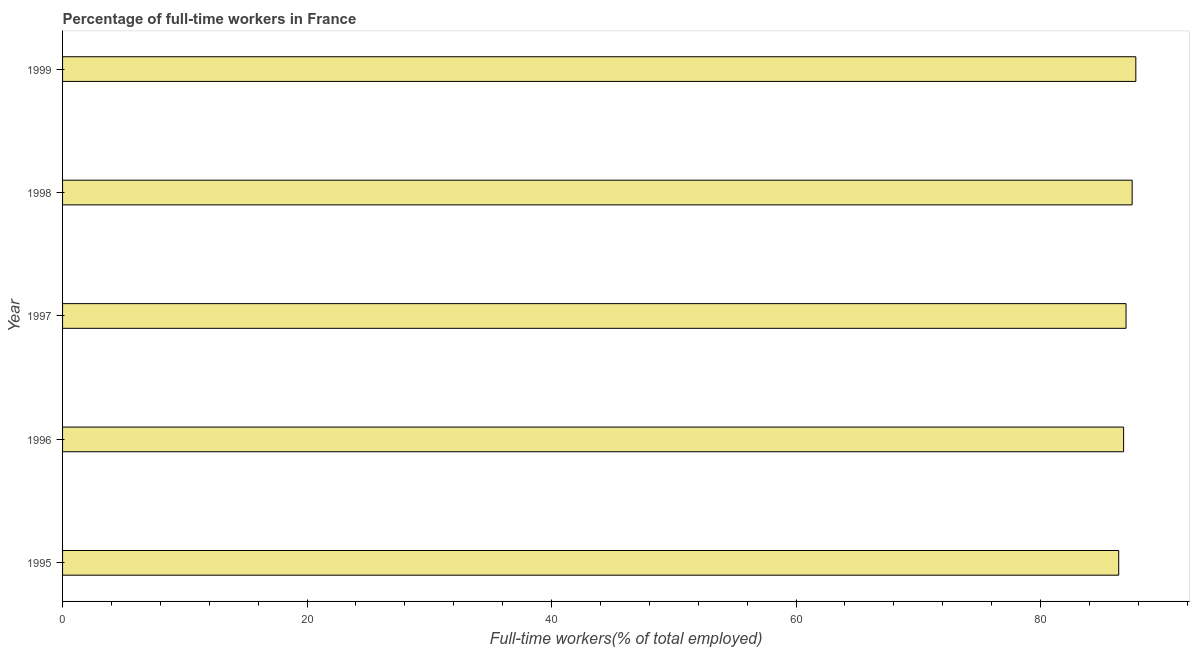What is the title of the graph?
Keep it short and to the point. Percentage of full-time workers in France. What is the label or title of the X-axis?
Provide a succinct answer. Full-time workers(% of total employed). What is the label or title of the Y-axis?
Your answer should be very brief. Year. Across all years, what is the maximum percentage of full-time workers?
Keep it short and to the point. 87.8. Across all years, what is the minimum percentage of full-time workers?
Your response must be concise. 86.4. In which year was the percentage of full-time workers minimum?
Provide a succinct answer. 1995. What is the sum of the percentage of full-time workers?
Ensure brevity in your answer.  435.5. What is the average percentage of full-time workers per year?
Give a very brief answer. 87.1. What is the median percentage of full-time workers?
Offer a very short reply. 87. In how many years, is the percentage of full-time workers greater than 52 %?
Offer a terse response. 5. Is the percentage of full-time workers in 1995 less than that in 1999?
Provide a succinct answer. Yes. What is the difference between the highest and the second highest percentage of full-time workers?
Make the answer very short. 0.3. How many bars are there?
Your answer should be compact. 5. How many years are there in the graph?
Your answer should be compact. 5. What is the difference between two consecutive major ticks on the X-axis?
Provide a short and direct response. 20. What is the Full-time workers(% of total employed) in 1995?
Your answer should be compact. 86.4. What is the Full-time workers(% of total employed) of 1996?
Your response must be concise. 86.8. What is the Full-time workers(% of total employed) of 1997?
Ensure brevity in your answer.  87. What is the Full-time workers(% of total employed) in 1998?
Your response must be concise. 87.5. What is the Full-time workers(% of total employed) in 1999?
Provide a short and direct response. 87.8. What is the difference between the Full-time workers(% of total employed) in 1995 and 1996?
Your answer should be compact. -0.4. What is the difference between the Full-time workers(% of total employed) in 1995 and 1998?
Provide a short and direct response. -1.1. What is the difference between the Full-time workers(% of total employed) in 1996 and 1997?
Your answer should be very brief. -0.2. What is the difference between the Full-time workers(% of total employed) in 1998 and 1999?
Offer a terse response. -0.3. What is the ratio of the Full-time workers(% of total employed) in 1995 to that in 1996?
Make the answer very short. 0.99. What is the ratio of the Full-time workers(% of total employed) in 1995 to that in 1997?
Your answer should be compact. 0.99. What is the ratio of the Full-time workers(% of total employed) in 1995 to that in 1999?
Offer a very short reply. 0.98. What is the ratio of the Full-time workers(% of total employed) in 1996 to that in 1997?
Provide a short and direct response. 1. What is the ratio of the Full-time workers(% of total employed) in 1996 to that in 1998?
Your answer should be compact. 0.99. What is the ratio of the Full-time workers(% of total employed) in 1997 to that in 1998?
Give a very brief answer. 0.99. What is the ratio of the Full-time workers(% of total employed) in 1997 to that in 1999?
Your answer should be compact. 0.99. 